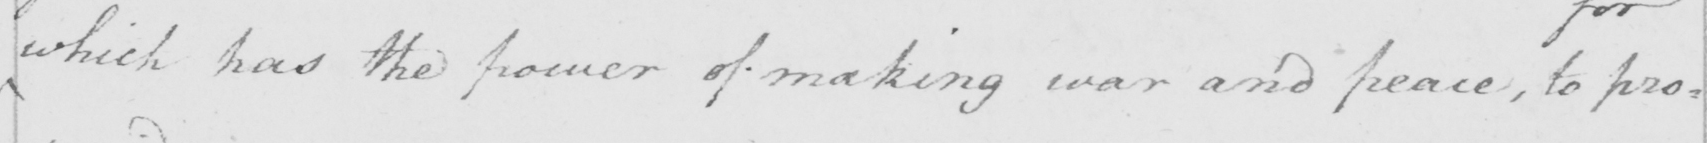What text is written in this handwritten line? which has the power of making war and peace  , to pro : 